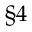<formula> <loc_0><loc_0><loc_500><loc_500>\S 4</formula> 